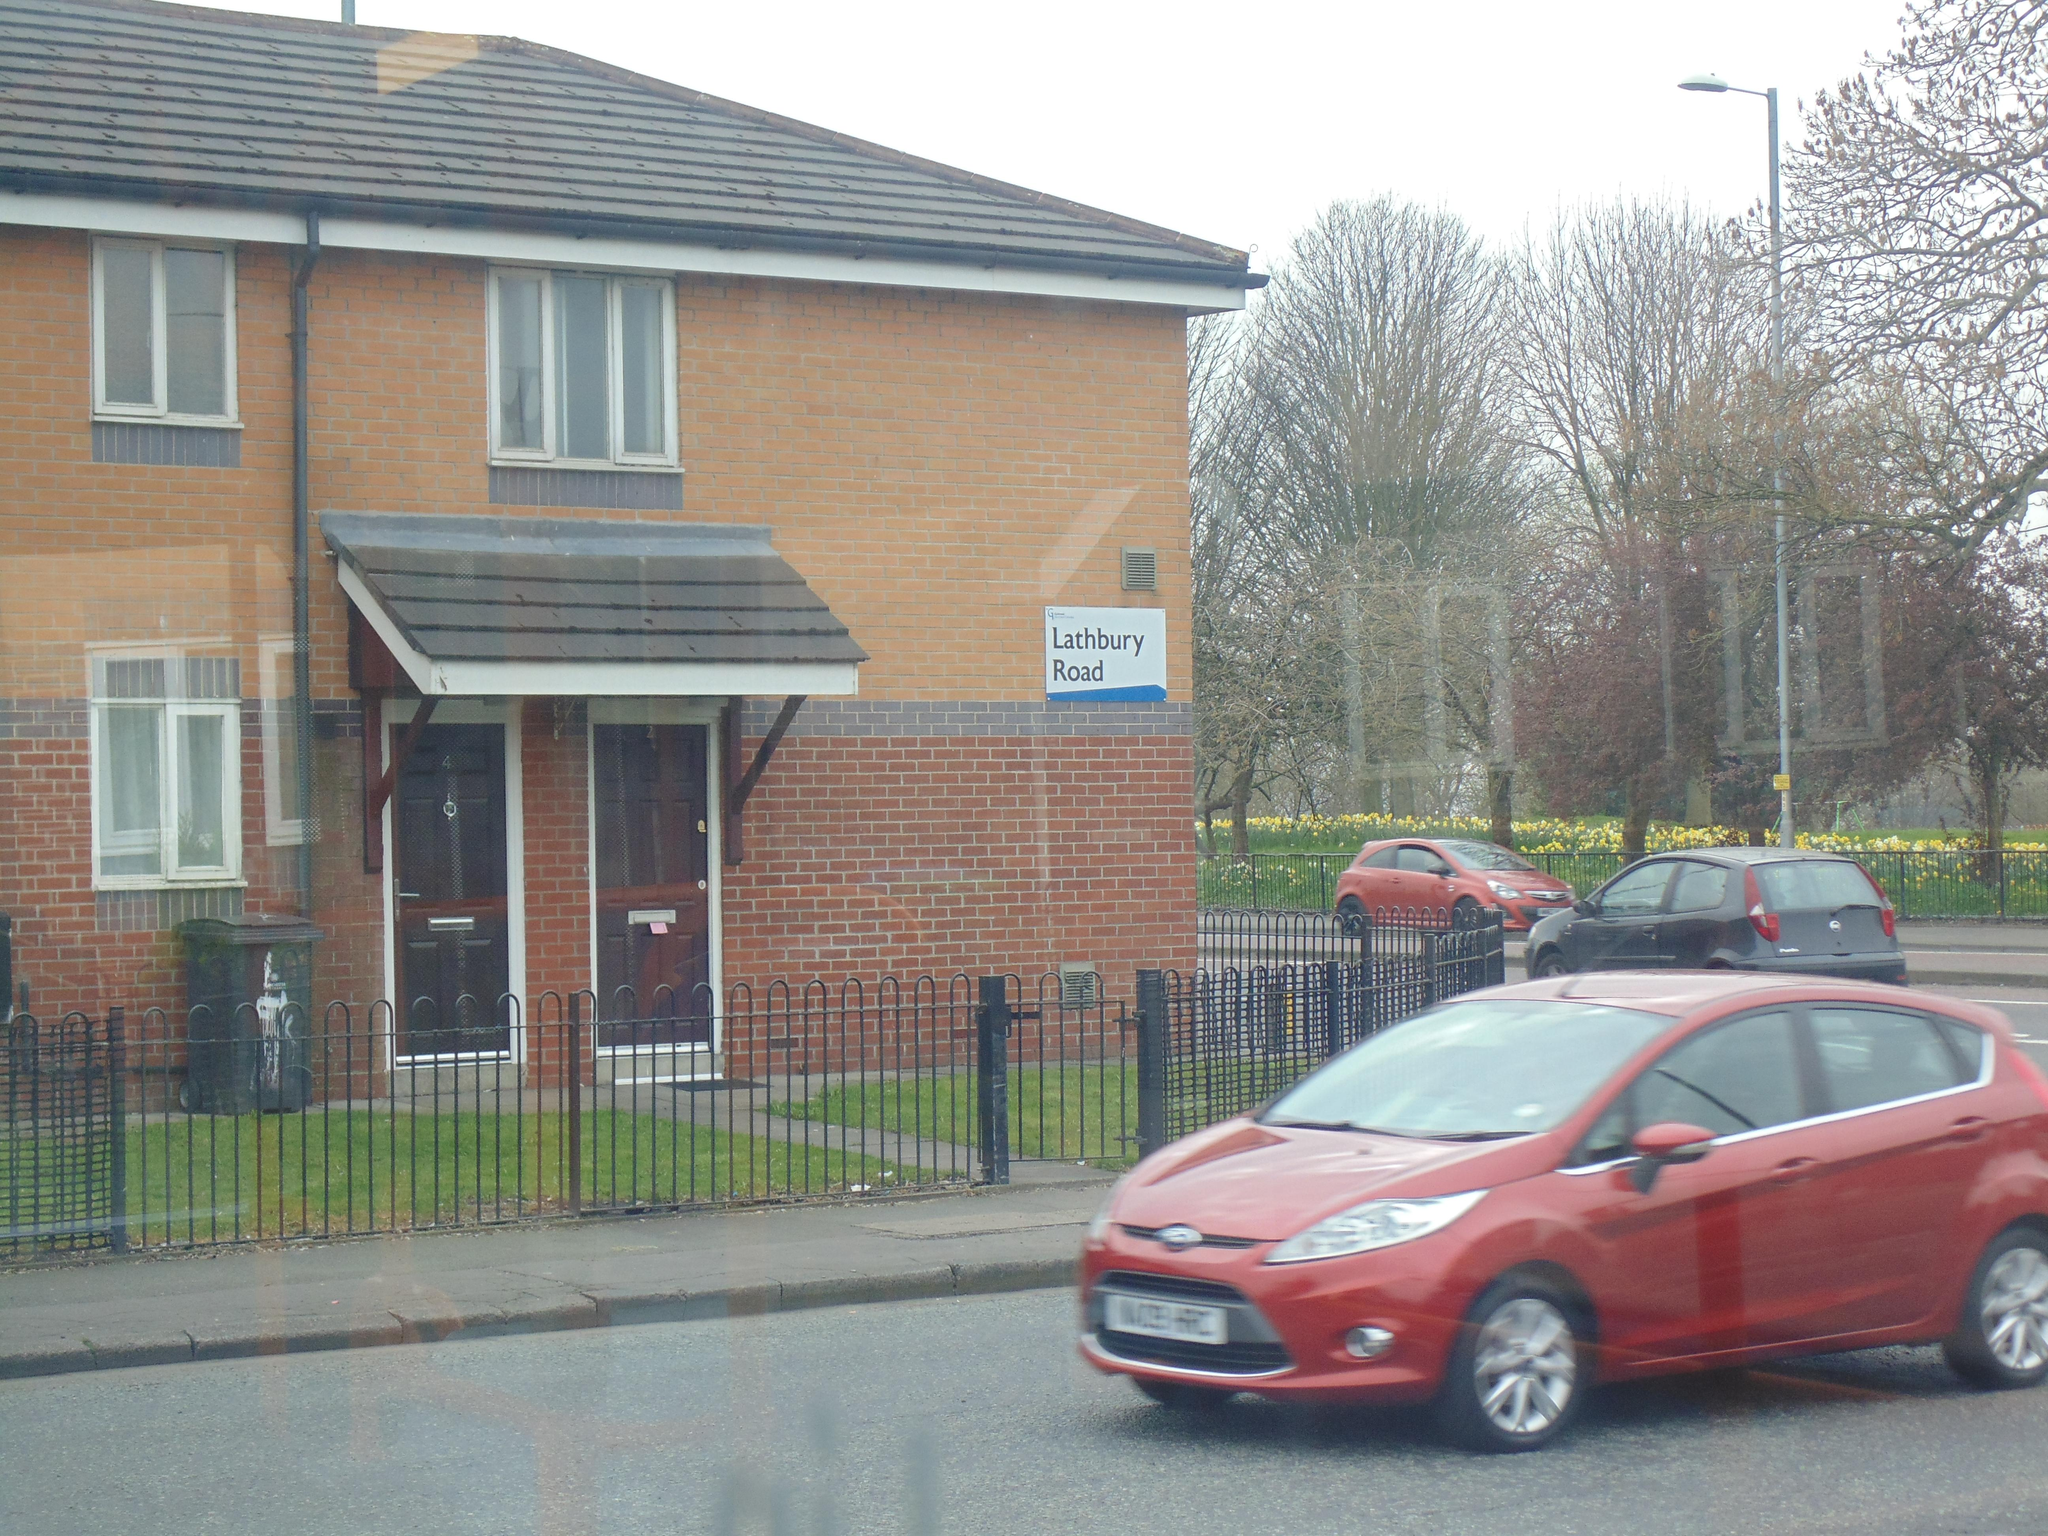What type of vehicles can be seen on the road in the image? There are cars on the road in the image. What structures can be seen in the image? There are fences, trees, buildings with windows, and a pole in the image. What is visible in the background of the image? The sky is visible in the background of the image. Can you tell me how many matches are being blown out by the thunder in the image? There are no matches, blowing, or thunder present in the image. 